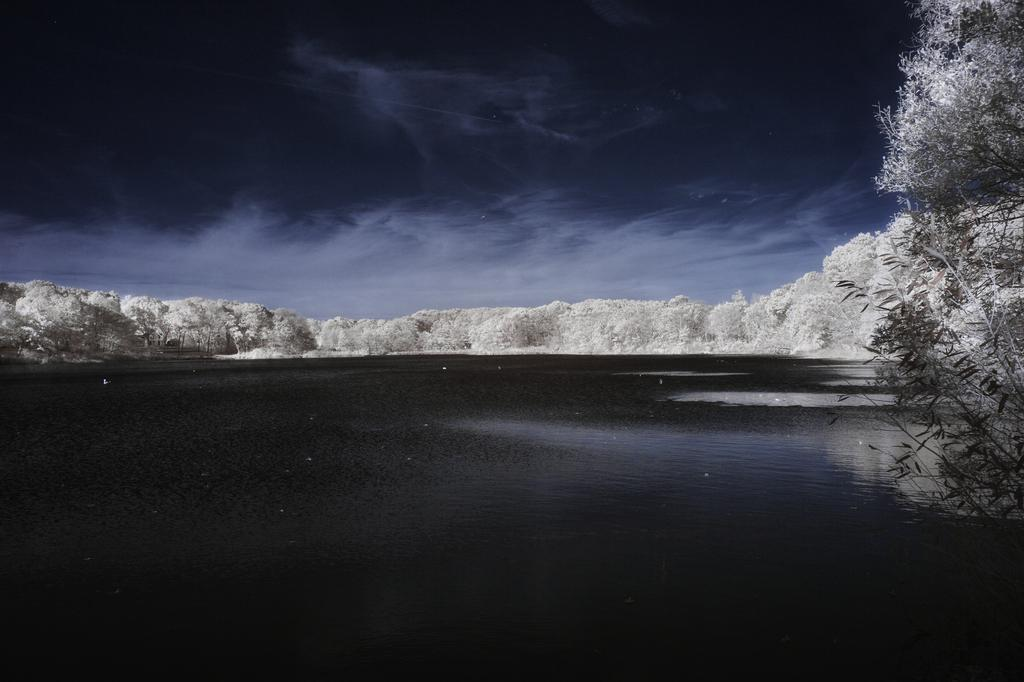What is visible in the image that is not solid? There is water visible in the image. What type of vegetation can be seen in the image? There are trees in the image. What part of the natural environment is visible in the image? The sky is visible in the image. What is the price of the bomb in the image? There is no bomb present in the image, so it is not possible to determine its price. 